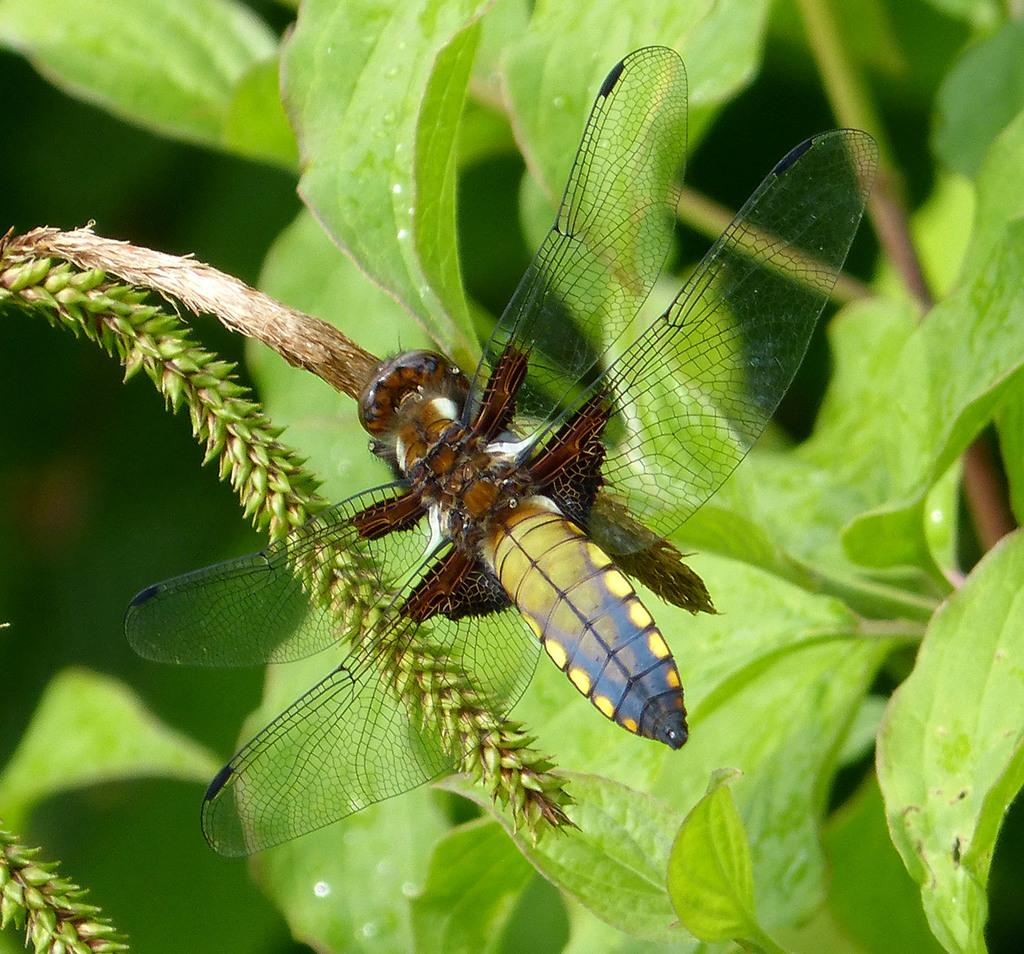What is present on the plant in the image? There is an insect on a plant in the image. What can be seen in the background of the image? There are plants in the background of the image. What type of linen is being used to reward the insect in the image? There is no linen or reward present in the image; it only features an insect on a plant and plants in the background. 